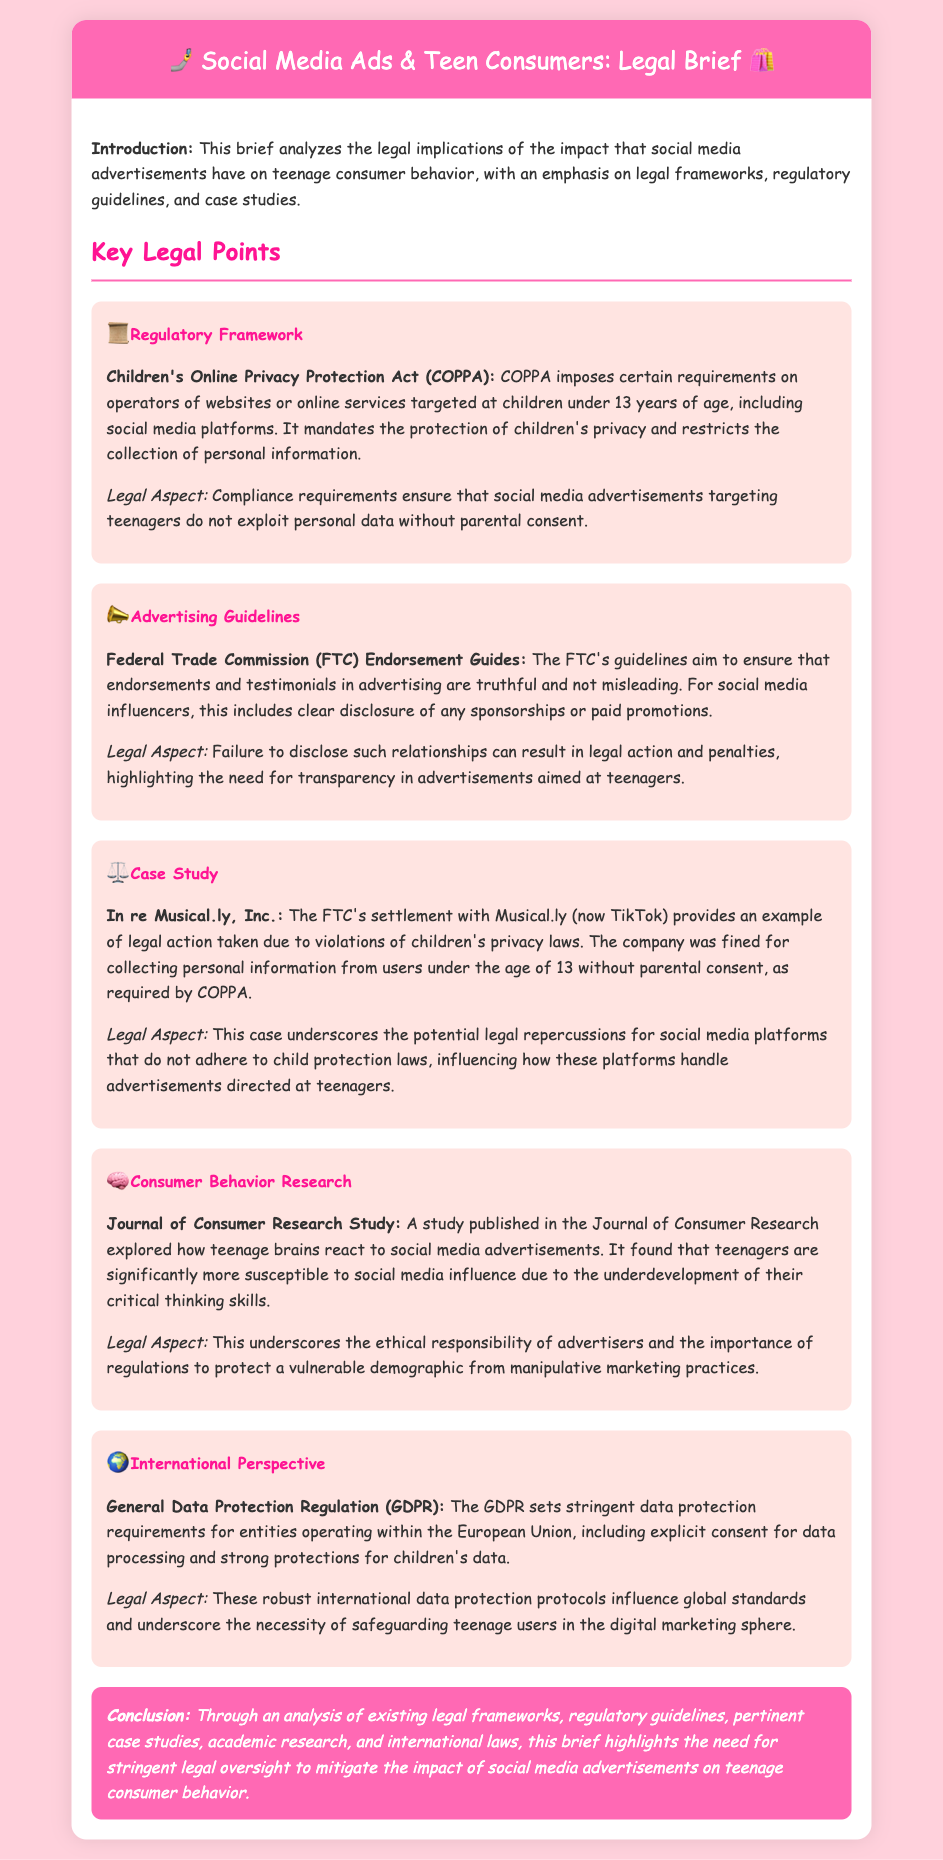What does COPPA stand for? COPPA is mentioned in the regulatory framework section of the document, referring to the Children's Online Privacy Protection Act.
Answer: Children's Online Privacy Protection Act What is one requirement of COPPA? The document states that COPPA mandates the protection of children's privacy and restricts the collection of personal information.
Answer: Protect children's privacy Who issues the endorsement guidelines for social media advertisements? The section on advertising guidelines mentions the organization associated with endorsement guidelines.
Answer: Federal Trade Commission What was the outcome of the FTC's settlement with Musical.ly, Inc.? The document notes that Musical.ly was fined for violations of privacy laws, highlighting legal repercussions.
Answer: Fined for violations What is one key finding of the Journal of Consumer Research study? The document highlights that teenagers are more susceptible to influence due to underdeveloped critical thinking skills.
Answer: More susceptible to social media influence What does GDPR stand for? The document includes mention of GDPR in the international perspective section.
Answer: General Data Protection Regulation What type of marketing practices does the document emphasize the need to protect against? The document discusses the importance of regulations to protect vulnerable demographics from manipulative marketing practices.
Answer: Manipulative marketing practices What is the main focus of the legal analysis in this brief? The introduction outlines that the main focus is on the impact of social media advertisements on teenage consumer behavior.
Answer: Impact of social media advertisements on teenage consumer behavior 